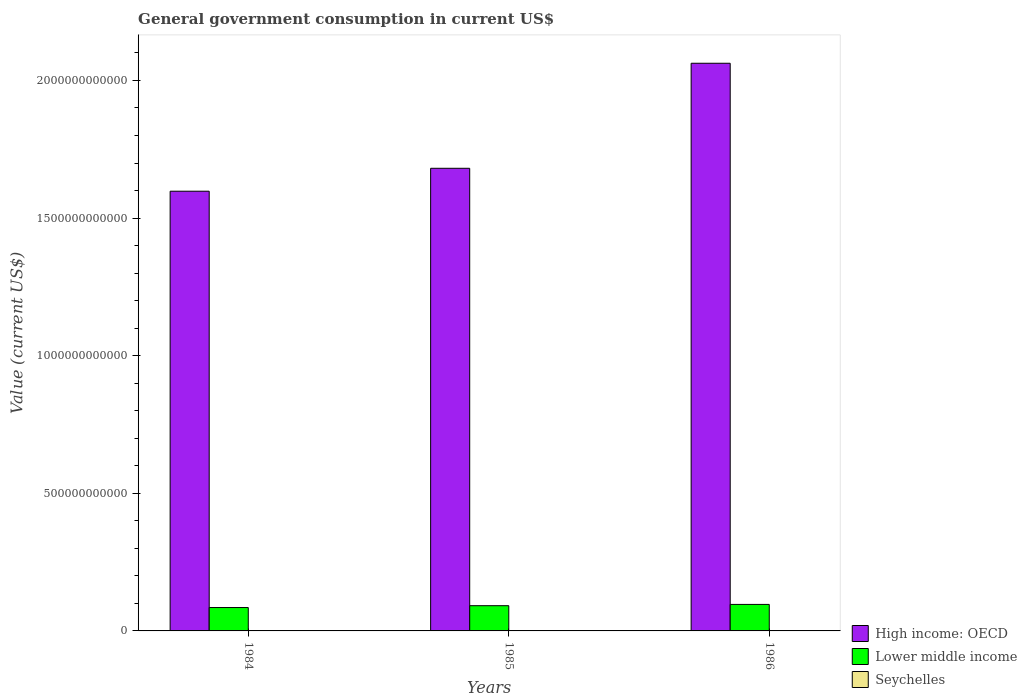How many different coloured bars are there?
Offer a terse response. 3. How many groups of bars are there?
Offer a terse response. 3. How many bars are there on the 3rd tick from the right?
Provide a succinct answer. 3. What is the label of the 1st group of bars from the left?
Your answer should be compact. 1984. What is the government conusmption in High income: OECD in 1985?
Your answer should be compact. 1.68e+12. Across all years, what is the maximum government conusmption in High income: OECD?
Provide a succinct answer. 2.06e+12. Across all years, what is the minimum government conusmption in Seychelles?
Ensure brevity in your answer.  4.64e+07. What is the total government conusmption in Lower middle income in the graph?
Provide a succinct answer. 2.73e+11. What is the difference between the government conusmption in Lower middle income in 1985 and that in 1986?
Provide a short and direct response. -4.69e+09. What is the difference between the government conusmption in High income: OECD in 1986 and the government conusmption in Lower middle income in 1984?
Give a very brief answer. 1.98e+12. What is the average government conusmption in High income: OECD per year?
Your answer should be very brief. 1.78e+12. In the year 1985, what is the difference between the government conusmption in Seychelles and government conusmption in High income: OECD?
Your answer should be very brief. -1.68e+12. In how many years, is the government conusmption in Seychelles greater than 800000000000 US$?
Your answer should be compact. 0. What is the ratio of the government conusmption in Lower middle income in 1985 to that in 1986?
Your response must be concise. 0.95. Is the government conusmption in High income: OECD in 1984 less than that in 1985?
Give a very brief answer. Yes. What is the difference between the highest and the second highest government conusmption in High income: OECD?
Keep it short and to the point. 3.82e+11. What is the difference between the highest and the lowest government conusmption in High income: OECD?
Provide a succinct answer. 4.65e+11. In how many years, is the government conusmption in Seychelles greater than the average government conusmption in Seychelles taken over all years?
Offer a terse response. 1. What does the 2nd bar from the left in 1985 represents?
Your answer should be very brief. Lower middle income. What does the 2nd bar from the right in 1985 represents?
Make the answer very short. Lower middle income. Is it the case that in every year, the sum of the government conusmption in Seychelles and government conusmption in High income: OECD is greater than the government conusmption in Lower middle income?
Your answer should be compact. Yes. What is the difference between two consecutive major ticks on the Y-axis?
Your answer should be very brief. 5.00e+11. Are the values on the major ticks of Y-axis written in scientific E-notation?
Offer a very short reply. No. Does the graph contain any zero values?
Keep it short and to the point. No. Does the graph contain grids?
Your response must be concise. No. How many legend labels are there?
Keep it short and to the point. 3. What is the title of the graph?
Your answer should be very brief. General government consumption in current US$. What is the label or title of the X-axis?
Your answer should be compact. Years. What is the label or title of the Y-axis?
Ensure brevity in your answer.  Value (current US$). What is the Value (current US$) in High income: OECD in 1984?
Provide a short and direct response. 1.60e+12. What is the Value (current US$) in Lower middle income in 1984?
Your response must be concise. 8.50e+1. What is the Value (current US$) in Seychelles in 1984?
Your answer should be compact. 4.64e+07. What is the Value (current US$) of High income: OECD in 1985?
Your answer should be compact. 1.68e+12. What is the Value (current US$) in Lower middle income in 1985?
Make the answer very short. 9.16e+1. What is the Value (current US$) in Seychelles in 1985?
Keep it short and to the point. 5.85e+07. What is the Value (current US$) of High income: OECD in 1986?
Provide a short and direct response. 2.06e+12. What is the Value (current US$) in Lower middle income in 1986?
Your answer should be compact. 9.63e+1. What is the Value (current US$) of Seychelles in 1986?
Make the answer very short. 8.06e+07. Across all years, what is the maximum Value (current US$) in High income: OECD?
Your response must be concise. 2.06e+12. Across all years, what is the maximum Value (current US$) in Lower middle income?
Keep it short and to the point. 9.63e+1. Across all years, what is the maximum Value (current US$) in Seychelles?
Your answer should be very brief. 8.06e+07. Across all years, what is the minimum Value (current US$) in High income: OECD?
Provide a succinct answer. 1.60e+12. Across all years, what is the minimum Value (current US$) of Lower middle income?
Give a very brief answer. 8.50e+1. Across all years, what is the minimum Value (current US$) of Seychelles?
Keep it short and to the point. 4.64e+07. What is the total Value (current US$) of High income: OECD in the graph?
Give a very brief answer. 5.34e+12. What is the total Value (current US$) of Lower middle income in the graph?
Provide a short and direct response. 2.73e+11. What is the total Value (current US$) of Seychelles in the graph?
Keep it short and to the point. 1.85e+08. What is the difference between the Value (current US$) in High income: OECD in 1984 and that in 1985?
Keep it short and to the point. -8.33e+1. What is the difference between the Value (current US$) in Lower middle income in 1984 and that in 1985?
Your answer should be very brief. -6.68e+09. What is the difference between the Value (current US$) in Seychelles in 1984 and that in 1985?
Your answer should be very brief. -1.21e+07. What is the difference between the Value (current US$) in High income: OECD in 1984 and that in 1986?
Give a very brief answer. -4.65e+11. What is the difference between the Value (current US$) in Lower middle income in 1984 and that in 1986?
Offer a terse response. -1.14e+1. What is the difference between the Value (current US$) of Seychelles in 1984 and that in 1986?
Provide a short and direct response. -3.41e+07. What is the difference between the Value (current US$) in High income: OECD in 1985 and that in 1986?
Make the answer very short. -3.82e+11. What is the difference between the Value (current US$) in Lower middle income in 1985 and that in 1986?
Offer a very short reply. -4.69e+09. What is the difference between the Value (current US$) of Seychelles in 1985 and that in 1986?
Provide a short and direct response. -2.21e+07. What is the difference between the Value (current US$) in High income: OECD in 1984 and the Value (current US$) in Lower middle income in 1985?
Keep it short and to the point. 1.51e+12. What is the difference between the Value (current US$) in High income: OECD in 1984 and the Value (current US$) in Seychelles in 1985?
Ensure brevity in your answer.  1.60e+12. What is the difference between the Value (current US$) of Lower middle income in 1984 and the Value (current US$) of Seychelles in 1985?
Offer a very short reply. 8.49e+1. What is the difference between the Value (current US$) of High income: OECD in 1984 and the Value (current US$) of Lower middle income in 1986?
Make the answer very short. 1.50e+12. What is the difference between the Value (current US$) in High income: OECD in 1984 and the Value (current US$) in Seychelles in 1986?
Your answer should be compact. 1.60e+12. What is the difference between the Value (current US$) in Lower middle income in 1984 and the Value (current US$) in Seychelles in 1986?
Make the answer very short. 8.49e+1. What is the difference between the Value (current US$) in High income: OECD in 1985 and the Value (current US$) in Lower middle income in 1986?
Offer a very short reply. 1.58e+12. What is the difference between the Value (current US$) in High income: OECD in 1985 and the Value (current US$) in Seychelles in 1986?
Offer a terse response. 1.68e+12. What is the difference between the Value (current US$) in Lower middle income in 1985 and the Value (current US$) in Seychelles in 1986?
Offer a terse response. 9.15e+1. What is the average Value (current US$) in High income: OECD per year?
Offer a very short reply. 1.78e+12. What is the average Value (current US$) of Lower middle income per year?
Your response must be concise. 9.10e+1. What is the average Value (current US$) of Seychelles per year?
Your answer should be compact. 6.18e+07. In the year 1984, what is the difference between the Value (current US$) in High income: OECD and Value (current US$) in Lower middle income?
Your answer should be very brief. 1.51e+12. In the year 1984, what is the difference between the Value (current US$) of High income: OECD and Value (current US$) of Seychelles?
Offer a very short reply. 1.60e+12. In the year 1984, what is the difference between the Value (current US$) in Lower middle income and Value (current US$) in Seychelles?
Your answer should be compact. 8.49e+1. In the year 1985, what is the difference between the Value (current US$) in High income: OECD and Value (current US$) in Lower middle income?
Offer a terse response. 1.59e+12. In the year 1985, what is the difference between the Value (current US$) of High income: OECD and Value (current US$) of Seychelles?
Provide a short and direct response. 1.68e+12. In the year 1985, what is the difference between the Value (current US$) in Lower middle income and Value (current US$) in Seychelles?
Provide a succinct answer. 9.16e+1. In the year 1986, what is the difference between the Value (current US$) in High income: OECD and Value (current US$) in Lower middle income?
Give a very brief answer. 1.97e+12. In the year 1986, what is the difference between the Value (current US$) in High income: OECD and Value (current US$) in Seychelles?
Provide a short and direct response. 2.06e+12. In the year 1986, what is the difference between the Value (current US$) in Lower middle income and Value (current US$) in Seychelles?
Your response must be concise. 9.62e+1. What is the ratio of the Value (current US$) of High income: OECD in 1984 to that in 1985?
Offer a terse response. 0.95. What is the ratio of the Value (current US$) of Lower middle income in 1984 to that in 1985?
Ensure brevity in your answer.  0.93. What is the ratio of the Value (current US$) of Seychelles in 1984 to that in 1985?
Keep it short and to the point. 0.79. What is the ratio of the Value (current US$) in High income: OECD in 1984 to that in 1986?
Make the answer very short. 0.77. What is the ratio of the Value (current US$) of Lower middle income in 1984 to that in 1986?
Give a very brief answer. 0.88. What is the ratio of the Value (current US$) in Seychelles in 1984 to that in 1986?
Your answer should be compact. 0.58. What is the ratio of the Value (current US$) in High income: OECD in 1985 to that in 1986?
Provide a succinct answer. 0.81. What is the ratio of the Value (current US$) of Lower middle income in 1985 to that in 1986?
Give a very brief answer. 0.95. What is the ratio of the Value (current US$) of Seychelles in 1985 to that in 1986?
Your answer should be compact. 0.73. What is the difference between the highest and the second highest Value (current US$) of High income: OECD?
Your answer should be compact. 3.82e+11. What is the difference between the highest and the second highest Value (current US$) in Lower middle income?
Your answer should be compact. 4.69e+09. What is the difference between the highest and the second highest Value (current US$) of Seychelles?
Offer a terse response. 2.21e+07. What is the difference between the highest and the lowest Value (current US$) in High income: OECD?
Provide a succinct answer. 4.65e+11. What is the difference between the highest and the lowest Value (current US$) in Lower middle income?
Ensure brevity in your answer.  1.14e+1. What is the difference between the highest and the lowest Value (current US$) in Seychelles?
Give a very brief answer. 3.41e+07. 